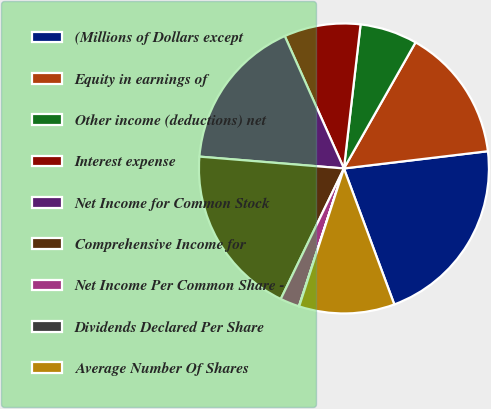Convert chart. <chart><loc_0><loc_0><loc_500><loc_500><pie_chart><fcel>(Millions of Dollars except<fcel>Equity in earnings of<fcel>Other income (deductions) net<fcel>Interest expense<fcel>Net Income for Common Stock<fcel>Comprehensive Income for<fcel>Net Income Per Common Share -<fcel>Dividends Declared Per Share<fcel>Average Number Of Shares<nl><fcel>21.25%<fcel>14.88%<fcel>6.39%<fcel>8.52%<fcel>17.01%<fcel>19.13%<fcel>2.15%<fcel>0.03%<fcel>10.64%<nl></chart> 